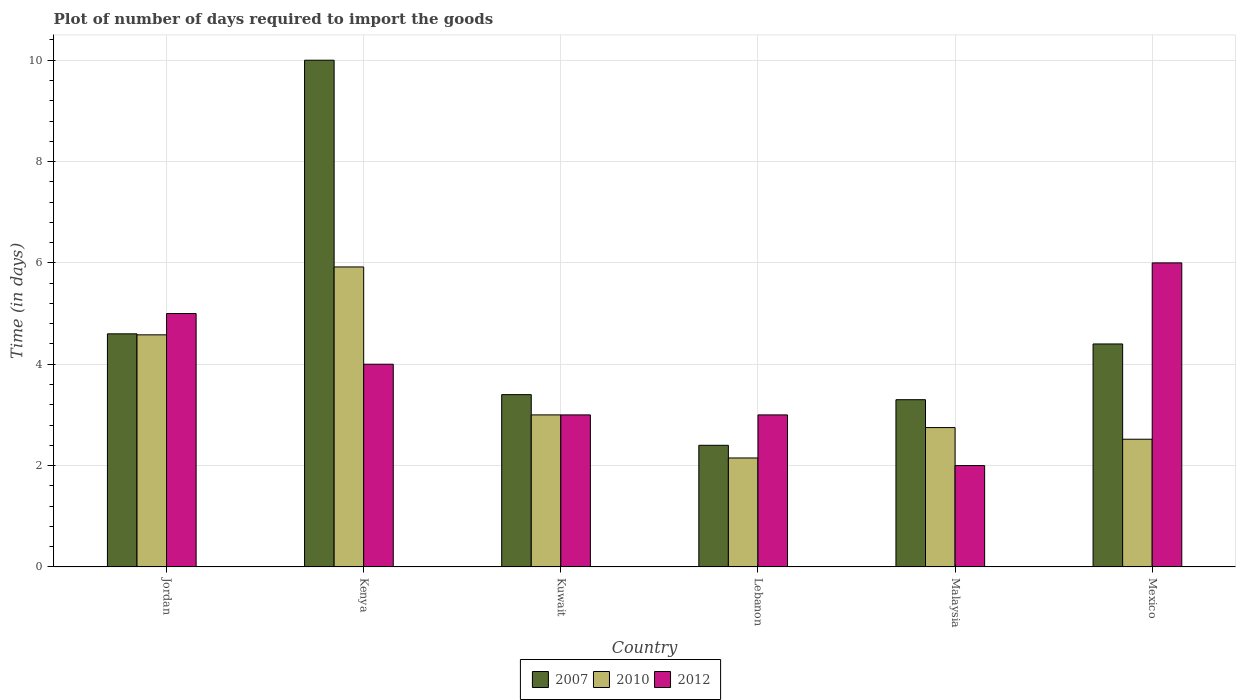How many different coloured bars are there?
Provide a succinct answer. 3. Are the number of bars per tick equal to the number of legend labels?
Offer a terse response. Yes. How many bars are there on the 4th tick from the left?
Give a very brief answer. 3. How many bars are there on the 3rd tick from the right?
Keep it short and to the point. 3. What is the label of the 4th group of bars from the left?
Offer a very short reply. Lebanon. What is the time required to import goods in 2010 in Jordan?
Your answer should be very brief. 4.58. In which country was the time required to import goods in 2007 maximum?
Keep it short and to the point. Kenya. In which country was the time required to import goods in 2007 minimum?
Make the answer very short. Lebanon. What is the total time required to import goods in 2007 in the graph?
Your answer should be compact. 28.1. What is the difference between the time required to import goods in 2012 in Kuwait and that in Malaysia?
Your answer should be compact. 1. What is the difference between the time required to import goods in 2010 in Jordan and the time required to import goods in 2012 in Kuwait?
Your answer should be compact. 1.58. What is the average time required to import goods in 2007 per country?
Give a very brief answer. 4.68. What is the difference between the time required to import goods of/in 2010 and time required to import goods of/in 2007 in Jordan?
Make the answer very short. -0.02. In how many countries, is the time required to import goods in 2012 greater than 4.4 days?
Keep it short and to the point. 2. What is the ratio of the time required to import goods in 2010 in Kuwait to that in Mexico?
Offer a very short reply. 1.19. What is the difference between the highest and the lowest time required to import goods in 2012?
Give a very brief answer. 4. Is the sum of the time required to import goods in 2007 in Jordan and Mexico greater than the maximum time required to import goods in 2012 across all countries?
Your answer should be very brief. Yes. How many bars are there?
Offer a terse response. 18. How many countries are there in the graph?
Provide a short and direct response. 6. Does the graph contain grids?
Offer a terse response. Yes. How many legend labels are there?
Keep it short and to the point. 3. What is the title of the graph?
Ensure brevity in your answer.  Plot of number of days required to import the goods. What is the label or title of the X-axis?
Provide a short and direct response. Country. What is the label or title of the Y-axis?
Offer a terse response. Time (in days). What is the Time (in days) of 2007 in Jordan?
Provide a short and direct response. 4.6. What is the Time (in days) in 2010 in Jordan?
Your answer should be compact. 4.58. What is the Time (in days) in 2010 in Kenya?
Your answer should be very brief. 5.92. What is the Time (in days) in 2012 in Kenya?
Your answer should be very brief. 4. What is the Time (in days) in 2007 in Kuwait?
Offer a very short reply. 3.4. What is the Time (in days) in 2007 in Lebanon?
Provide a short and direct response. 2.4. What is the Time (in days) of 2010 in Lebanon?
Ensure brevity in your answer.  2.15. What is the Time (in days) of 2012 in Lebanon?
Ensure brevity in your answer.  3. What is the Time (in days) in 2010 in Malaysia?
Give a very brief answer. 2.75. What is the Time (in days) in 2010 in Mexico?
Make the answer very short. 2.52. What is the Time (in days) in 2012 in Mexico?
Your answer should be very brief. 6. Across all countries, what is the maximum Time (in days) in 2007?
Offer a terse response. 10. Across all countries, what is the maximum Time (in days) in 2010?
Provide a short and direct response. 5.92. Across all countries, what is the maximum Time (in days) in 2012?
Give a very brief answer. 6. Across all countries, what is the minimum Time (in days) of 2010?
Ensure brevity in your answer.  2.15. What is the total Time (in days) in 2007 in the graph?
Give a very brief answer. 28.1. What is the total Time (in days) of 2010 in the graph?
Give a very brief answer. 20.92. What is the total Time (in days) of 2012 in the graph?
Give a very brief answer. 23. What is the difference between the Time (in days) of 2010 in Jordan and that in Kenya?
Your answer should be very brief. -1.34. What is the difference between the Time (in days) of 2012 in Jordan and that in Kenya?
Provide a succinct answer. 1. What is the difference between the Time (in days) of 2007 in Jordan and that in Kuwait?
Make the answer very short. 1.2. What is the difference between the Time (in days) of 2010 in Jordan and that in Kuwait?
Ensure brevity in your answer.  1.58. What is the difference between the Time (in days) in 2010 in Jordan and that in Lebanon?
Provide a succinct answer. 2.43. What is the difference between the Time (in days) of 2007 in Jordan and that in Malaysia?
Provide a short and direct response. 1.3. What is the difference between the Time (in days) in 2010 in Jordan and that in Malaysia?
Keep it short and to the point. 1.83. What is the difference between the Time (in days) of 2007 in Jordan and that in Mexico?
Keep it short and to the point. 0.2. What is the difference between the Time (in days) in 2010 in Jordan and that in Mexico?
Provide a short and direct response. 2.06. What is the difference between the Time (in days) of 2007 in Kenya and that in Kuwait?
Your answer should be very brief. 6.6. What is the difference between the Time (in days) in 2010 in Kenya and that in Kuwait?
Give a very brief answer. 2.92. What is the difference between the Time (in days) of 2007 in Kenya and that in Lebanon?
Offer a terse response. 7.6. What is the difference between the Time (in days) of 2010 in Kenya and that in Lebanon?
Your answer should be compact. 3.77. What is the difference between the Time (in days) of 2012 in Kenya and that in Lebanon?
Your answer should be very brief. 1. What is the difference between the Time (in days) of 2010 in Kenya and that in Malaysia?
Offer a very short reply. 3.17. What is the difference between the Time (in days) of 2012 in Kenya and that in Malaysia?
Your response must be concise. 2. What is the difference between the Time (in days) of 2010 in Kenya and that in Mexico?
Keep it short and to the point. 3.4. What is the difference between the Time (in days) in 2007 in Kuwait and that in Lebanon?
Give a very brief answer. 1. What is the difference between the Time (in days) of 2012 in Kuwait and that in Lebanon?
Offer a very short reply. 0. What is the difference between the Time (in days) of 2007 in Kuwait and that in Malaysia?
Your response must be concise. 0.1. What is the difference between the Time (in days) of 2010 in Kuwait and that in Malaysia?
Ensure brevity in your answer.  0.25. What is the difference between the Time (in days) in 2012 in Kuwait and that in Malaysia?
Make the answer very short. 1. What is the difference between the Time (in days) in 2007 in Kuwait and that in Mexico?
Make the answer very short. -1. What is the difference between the Time (in days) of 2010 in Kuwait and that in Mexico?
Your answer should be very brief. 0.48. What is the difference between the Time (in days) in 2007 in Lebanon and that in Malaysia?
Ensure brevity in your answer.  -0.9. What is the difference between the Time (in days) of 2007 in Lebanon and that in Mexico?
Keep it short and to the point. -2. What is the difference between the Time (in days) in 2010 in Lebanon and that in Mexico?
Offer a very short reply. -0.37. What is the difference between the Time (in days) of 2007 in Malaysia and that in Mexico?
Your response must be concise. -1.1. What is the difference between the Time (in days) of 2010 in Malaysia and that in Mexico?
Offer a terse response. 0.23. What is the difference between the Time (in days) in 2007 in Jordan and the Time (in days) in 2010 in Kenya?
Offer a terse response. -1.32. What is the difference between the Time (in days) in 2010 in Jordan and the Time (in days) in 2012 in Kenya?
Your answer should be very brief. 0.58. What is the difference between the Time (in days) in 2007 in Jordan and the Time (in days) in 2010 in Kuwait?
Make the answer very short. 1.6. What is the difference between the Time (in days) in 2010 in Jordan and the Time (in days) in 2012 in Kuwait?
Provide a short and direct response. 1.58. What is the difference between the Time (in days) of 2007 in Jordan and the Time (in days) of 2010 in Lebanon?
Give a very brief answer. 2.45. What is the difference between the Time (in days) of 2010 in Jordan and the Time (in days) of 2012 in Lebanon?
Offer a terse response. 1.58. What is the difference between the Time (in days) of 2007 in Jordan and the Time (in days) of 2010 in Malaysia?
Offer a terse response. 1.85. What is the difference between the Time (in days) in 2007 in Jordan and the Time (in days) in 2012 in Malaysia?
Provide a short and direct response. 2.6. What is the difference between the Time (in days) in 2010 in Jordan and the Time (in days) in 2012 in Malaysia?
Your answer should be very brief. 2.58. What is the difference between the Time (in days) in 2007 in Jordan and the Time (in days) in 2010 in Mexico?
Your answer should be compact. 2.08. What is the difference between the Time (in days) of 2010 in Jordan and the Time (in days) of 2012 in Mexico?
Offer a terse response. -1.42. What is the difference between the Time (in days) in 2007 in Kenya and the Time (in days) in 2012 in Kuwait?
Offer a very short reply. 7. What is the difference between the Time (in days) in 2010 in Kenya and the Time (in days) in 2012 in Kuwait?
Ensure brevity in your answer.  2.92. What is the difference between the Time (in days) of 2007 in Kenya and the Time (in days) of 2010 in Lebanon?
Keep it short and to the point. 7.85. What is the difference between the Time (in days) in 2007 in Kenya and the Time (in days) in 2012 in Lebanon?
Provide a short and direct response. 7. What is the difference between the Time (in days) of 2010 in Kenya and the Time (in days) of 2012 in Lebanon?
Provide a short and direct response. 2.92. What is the difference between the Time (in days) of 2007 in Kenya and the Time (in days) of 2010 in Malaysia?
Offer a very short reply. 7.25. What is the difference between the Time (in days) in 2010 in Kenya and the Time (in days) in 2012 in Malaysia?
Offer a very short reply. 3.92. What is the difference between the Time (in days) of 2007 in Kenya and the Time (in days) of 2010 in Mexico?
Offer a very short reply. 7.48. What is the difference between the Time (in days) in 2010 in Kenya and the Time (in days) in 2012 in Mexico?
Provide a succinct answer. -0.08. What is the difference between the Time (in days) of 2007 in Kuwait and the Time (in days) of 2010 in Malaysia?
Make the answer very short. 0.65. What is the difference between the Time (in days) of 2007 in Kuwait and the Time (in days) of 2012 in Malaysia?
Offer a terse response. 1.4. What is the difference between the Time (in days) in 2007 in Kuwait and the Time (in days) in 2010 in Mexico?
Provide a short and direct response. 0.88. What is the difference between the Time (in days) in 2007 in Lebanon and the Time (in days) in 2010 in Malaysia?
Give a very brief answer. -0.35. What is the difference between the Time (in days) of 2007 in Lebanon and the Time (in days) of 2012 in Malaysia?
Provide a short and direct response. 0.4. What is the difference between the Time (in days) in 2007 in Lebanon and the Time (in days) in 2010 in Mexico?
Give a very brief answer. -0.12. What is the difference between the Time (in days) of 2007 in Lebanon and the Time (in days) of 2012 in Mexico?
Your response must be concise. -3.6. What is the difference between the Time (in days) in 2010 in Lebanon and the Time (in days) in 2012 in Mexico?
Make the answer very short. -3.85. What is the difference between the Time (in days) of 2007 in Malaysia and the Time (in days) of 2010 in Mexico?
Your answer should be compact. 0.78. What is the difference between the Time (in days) in 2010 in Malaysia and the Time (in days) in 2012 in Mexico?
Your answer should be compact. -3.25. What is the average Time (in days) in 2007 per country?
Give a very brief answer. 4.68. What is the average Time (in days) of 2010 per country?
Make the answer very short. 3.49. What is the average Time (in days) in 2012 per country?
Your answer should be very brief. 3.83. What is the difference between the Time (in days) of 2010 and Time (in days) of 2012 in Jordan?
Your answer should be very brief. -0.42. What is the difference between the Time (in days) of 2007 and Time (in days) of 2010 in Kenya?
Your answer should be very brief. 4.08. What is the difference between the Time (in days) of 2007 and Time (in days) of 2012 in Kenya?
Offer a terse response. 6. What is the difference between the Time (in days) in 2010 and Time (in days) in 2012 in Kenya?
Give a very brief answer. 1.92. What is the difference between the Time (in days) in 2007 and Time (in days) in 2010 in Kuwait?
Keep it short and to the point. 0.4. What is the difference between the Time (in days) of 2010 and Time (in days) of 2012 in Lebanon?
Your answer should be compact. -0.85. What is the difference between the Time (in days) in 2007 and Time (in days) in 2010 in Malaysia?
Your response must be concise. 0.55. What is the difference between the Time (in days) of 2007 and Time (in days) of 2012 in Malaysia?
Ensure brevity in your answer.  1.3. What is the difference between the Time (in days) of 2007 and Time (in days) of 2010 in Mexico?
Make the answer very short. 1.88. What is the difference between the Time (in days) in 2007 and Time (in days) in 2012 in Mexico?
Offer a very short reply. -1.6. What is the difference between the Time (in days) of 2010 and Time (in days) of 2012 in Mexico?
Your response must be concise. -3.48. What is the ratio of the Time (in days) of 2007 in Jordan to that in Kenya?
Your answer should be compact. 0.46. What is the ratio of the Time (in days) of 2010 in Jordan to that in Kenya?
Your answer should be compact. 0.77. What is the ratio of the Time (in days) in 2007 in Jordan to that in Kuwait?
Offer a terse response. 1.35. What is the ratio of the Time (in days) in 2010 in Jordan to that in Kuwait?
Provide a succinct answer. 1.53. What is the ratio of the Time (in days) of 2012 in Jordan to that in Kuwait?
Offer a terse response. 1.67. What is the ratio of the Time (in days) in 2007 in Jordan to that in Lebanon?
Offer a very short reply. 1.92. What is the ratio of the Time (in days) of 2010 in Jordan to that in Lebanon?
Your answer should be very brief. 2.13. What is the ratio of the Time (in days) of 2012 in Jordan to that in Lebanon?
Give a very brief answer. 1.67. What is the ratio of the Time (in days) of 2007 in Jordan to that in Malaysia?
Provide a succinct answer. 1.39. What is the ratio of the Time (in days) of 2010 in Jordan to that in Malaysia?
Your response must be concise. 1.67. What is the ratio of the Time (in days) of 2012 in Jordan to that in Malaysia?
Offer a terse response. 2.5. What is the ratio of the Time (in days) in 2007 in Jordan to that in Mexico?
Provide a succinct answer. 1.05. What is the ratio of the Time (in days) of 2010 in Jordan to that in Mexico?
Give a very brief answer. 1.82. What is the ratio of the Time (in days) in 2007 in Kenya to that in Kuwait?
Offer a very short reply. 2.94. What is the ratio of the Time (in days) of 2010 in Kenya to that in Kuwait?
Your response must be concise. 1.97. What is the ratio of the Time (in days) of 2007 in Kenya to that in Lebanon?
Your answer should be very brief. 4.17. What is the ratio of the Time (in days) of 2010 in Kenya to that in Lebanon?
Offer a very short reply. 2.75. What is the ratio of the Time (in days) in 2012 in Kenya to that in Lebanon?
Keep it short and to the point. 1.33. What is the ratio of the Time (in days) of 2007 in Kenya to that in Malaysia?
Offer a terse response. 3.03. What is the ratio of the Time (in days) of 2010 in Kenya to that in Malaysia?
Your answer should be compact. 2.15. What is the ratio of the Time (in days) of 2012 in Kenya to that in Malaysia?
Offer a very short reply. 2. What is the ratio of the Time (in days) in 2007 in Kenya to that in Mexico?
Your answer should be very brief. 2.27. What is the ratio of the Time (in days) in 2010 in Kenya to that in Mexico?
Give a very brief answer. 2.35. What is the ratio of the Time (in days) of 2007 in Kuwait to that in Lebanon?
Your response must be concise. 1.42. What is the ratio of the Time (in days) in 2010 in Kuwait to that in Lebanon?
Provide a succinct answer. 1.4. What is the ratio of the Time (in days) in 2007 in Kuwait to that in Malaysia?
Offer a very short reply. 1.03. What is the ratio of the Time (in days) in 2010 in Kuwait to that in Malaysia?
Offer a very short reply. 1.09. What is the ratio of the Time (in days) in 2007 in Kuwait to that in Mexico?
Ensure brevity in your answer.  0.77. What is the ratio of the Time (in days) of 2010 in Kuwait to that in Mexico?
Your answer should be very brief. 1.19. What is the ratio of the Time (in days) in 2007 in Lebanon to that in Malaysia?
Your response must be concise. 0.73. What is the ratio of the Time (in days) in 2010 in Lebanon to that in Malaysia?
Your answer should be very brief. 0.78. What is the ratio of the Time (in days) in 2007 in Lebanon to that in Mexico?
Provide a short and direct response. 0.55. What is the ratio of the Time (in days) of 2010 in Lebanon to that in Mexico?
Give a very brief answer. 0.85. What is the ratio of the Time (in days) of 2012 in Lebanon to that in Mexico?
Provide a succinct answer. 0.5. What is the ratio of the Time (in days) in 2010 in Malaysia to that in Mexico?
Make the answer very short. 1.09. What is the difference between the highest and the second highest Time (in days) of 2010?
Give a very brief answer. 1.34. What is the difference between the highest and the second highest Time (in days) of 2012?
Provide a short and direct response. 1. What is the difference between the highest and the lowest Time (in days) in 2010?
Your answer should be compact. 3.77. 